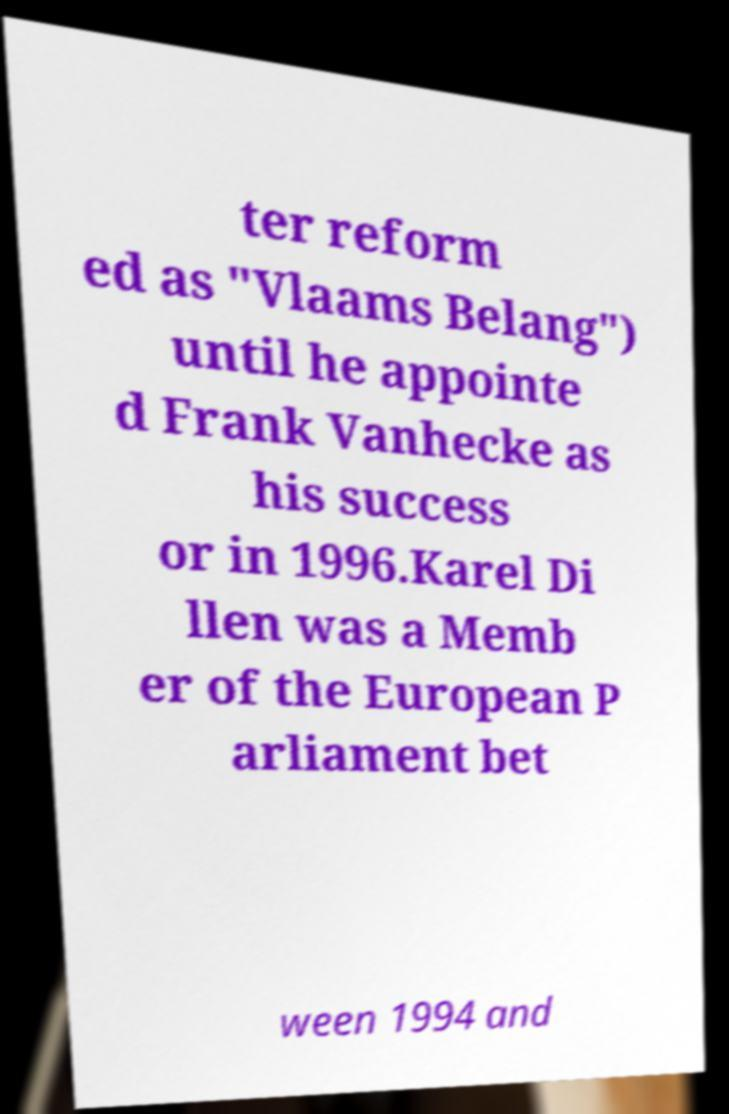Could you assist in decoding the text presented in this image and type it out clearly? ter reform ed as "Vlaams Belang") until he appointe d Frank Vanhecke as his success or in 1996.Karel Di llen was a Memb er of the European P arliament bet ween 1994 and 